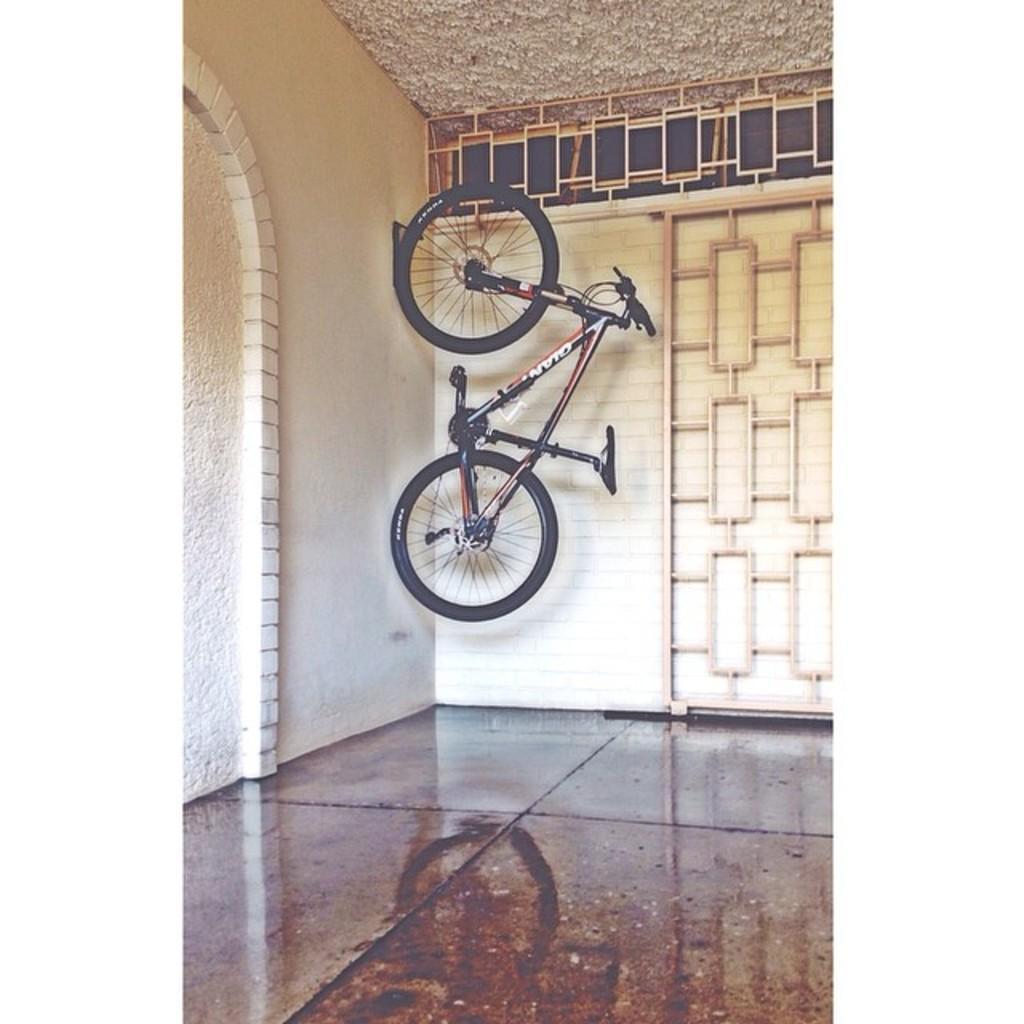In one or two sentences, can you explain what this image depicts? In this image there is a cycle hanged on the wall. In the back there is a wall. Also there is a railing. 